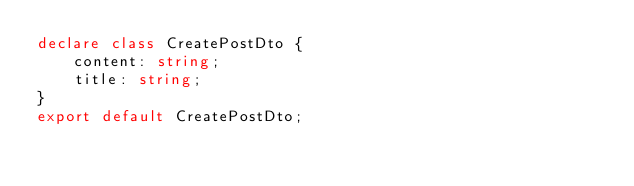<code> <loc_0><loc_0><loc_500><loc_500><_TypeScript_>declare class CreatePostDto {
    content: string;
    title: string;
}
export default CreatePostDto;
</code> 